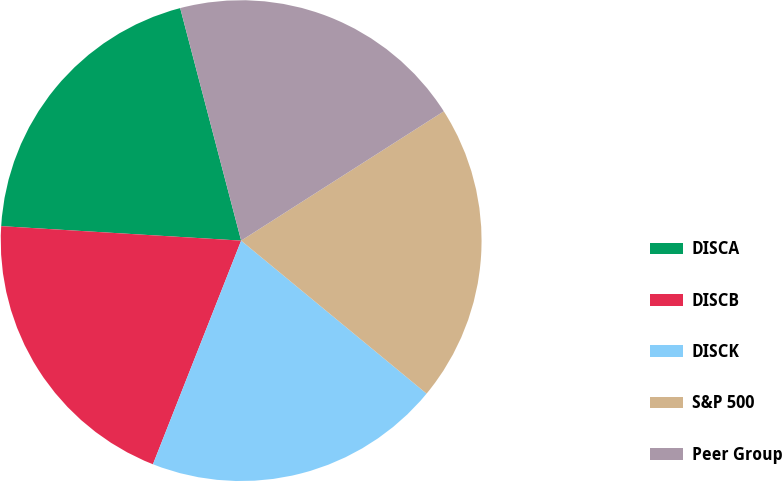<chart> <loc_0><loc_0><loc_500><loc_500><pie_chart><fcel>DISCA<fcel>DISCB<fcel>DISCK<fcel>S&P 500<fcel>Peer Group<nl><fcel>19.96%<fcel>19.98%<fcel>20.0%<fcel>20.02%<fcel>20.04%<nl></chart> 